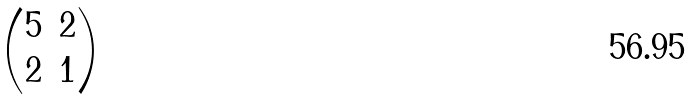Convert formula to latex. <formula><loc_0><loc_0><loc_500><loc_500>\begin{pmatrix} 5 & 2 \\ 2 & 1 \end{pmatrix}</formula> 